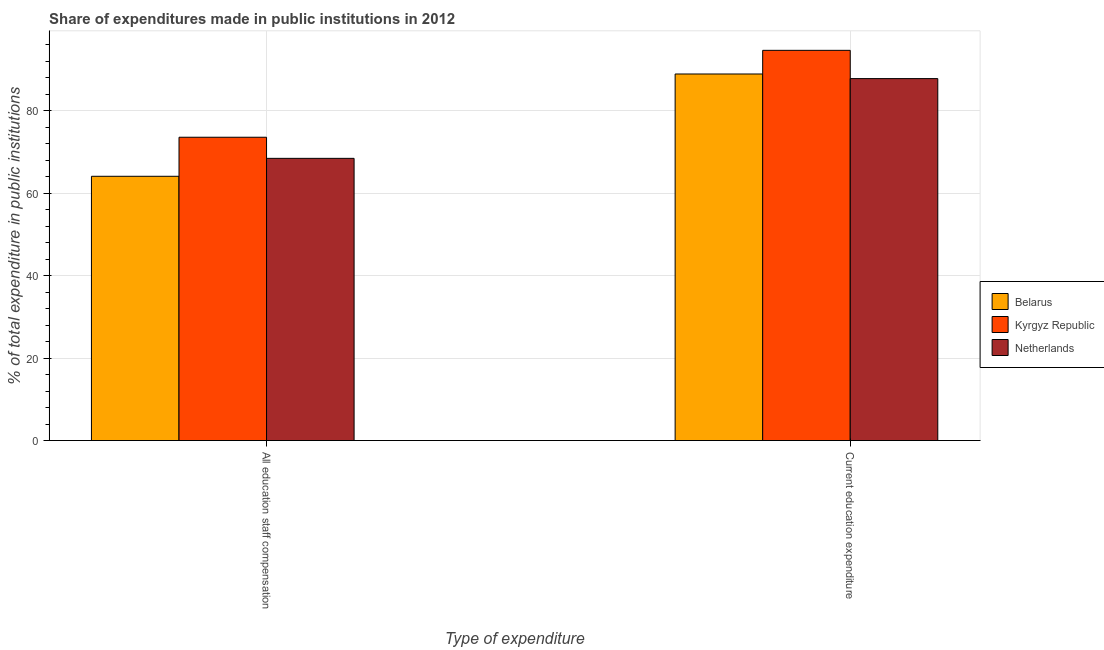How many different coloured bars are there?
Make the answer very short. 3. Are the number of bars per tick equal to the number of legend labels?
Ensure brevity in your answer.  Yes. How many bars are there on the 2nd tick from the right?
Give a very brief answer. 3. What is the label of the 1st group of bars from the left?
Your answer should be compact. All education staff compensation. What is the expenditure in staff compensation in Netherlands?
Make the answer very short. 68.41. Across all countries, what is the maximum expenditure in staff compensation?
Offer a terse response. 73.53. Across all countries, what is the minimum expenditure in staff compensation?
Your answer should be very brief. 64.06. In which country was the expenditure in staff compensation maximum?
Offer a very short reply. Kyrgyz Republic. What is the total expenditure in education in the graph?
Your answer should be compact. 271.19. What is the difference between the expenditure in education in Belarus and that in Netherlands?
Your answer should be very brief. 1.11. What is the difference between the expenditure in staff compensation in Netherlands and the expenditure in education in Kyrgyz Republic?
Provide a short and direct response. -26.18. What is the average expenditure in staff compensation per country?
Your answer should be very brief. 68.66. What is the difference between the expenditure in education and expenditure in staff compensation in Belarus?
Ensure brevity in your answer.  24.79. In how many countries, is the expenditure in staff compensation greater than 12 %?
Keep it short and to the point. 3. What is the ratio of the expenditure in education in Netherlands to that in Kyrgyz Republic?
Provide a short and direct response. 0.93. Is the expenditure in education in Netherlands less than that in Belarus?
Provide a succinct answer. Yes. What does the 1st bar from the left in Current education expenditure represents?
Ensure brevity in your answer.  Belarus. What does the 2nd bar from the right in Current education expenditure represents?
Provide a short and direct response. Kyrgyz Republic. Are all the bars in the graph horizontal?
Your answer should be compact. No. Does the graph contain any zero values?
Provide a succinct answer. No. Where does the legend appear in the graph?
Offer a terse response. Center right. What is the title of the graph?
Your answer should be very brief. Share of expenditures made in public institutions in 2012. What is the label or title of the X-axis?
Provide a succinct answer. Type of expenditure. What is the label or title of the Y-axis?
Provide a succinct answer. % of total expenditure in public institutions. What is the % of total expenditure in public institutions in Belarus in All education staff compensation?
Offer a terse response. 64.06. What is the % of total expenditure in public institutions in Kyrgyz Republic in All education staff compensation?
Give a very brief answer. 73.53. What is the % of total expenditure in public institutions in Netherlands in All education staff compensation?
Your response must be concise. 68.41. What is the % of total expenditure in public institutions of Belarus in Current education expenditure?
Provide a succinct answer. 88.86. What is the % of total expenditure in public institutions in Kyrgyz Republic in Current education expenditure?
Ensure brevity in your answer.  94.59. What is the % of total expenditure in public institutions of Netherlands in Current education expenditure?
Your answer should be compact. 87.74. Across all Type of expenditure, what is the maximum % of total expenditure in public institutions of Belarus?
Your answer should be compact. 88.86. Across all Type of expenditure, what is the maximum % of total expenditure in public institutions in Kyrgyz Republic?
Your answer should be compact. 94.59. Across all Type of expenditure, what is the maximum % of total expenditure in public institutions in Netherlands?
Give a very brief answer. 87.74. Across all Type of expenditure, what is the minimum % of total expenditure in public institutions of Belarus?
Offer a very short reply. 64.06. Across all Type of expenditure, what is the minimum % of total expenditure in public institutions in Kyrgyz Republic?
Provide a short and direct response. 73.53. Across all Type of expenditure, what is the minimum % of total expenditure in public institutions of Netherlands?
Your answer should be very brief. 68.41. What is the total % of total expenditure in public institutions of Belarus in the graph?
Provide a succinct answer. 152.92. What is the total % of total expenditure in public institutions of Kyrgyz Republic in the graph?
Give a very brief answer. 168.12. What is the total % of total expenditure in public institutions of Netherlands in the graph?
Give a very brief answer. 156.15. What is the difference between the % of total expenditure in public institutions of Belarus in All education staff compensation and that in Current education expenditure?
Provide a succinct answer. -24.79. What is the difference between the % of total expenditure in public institutions of Kyrgyz Republic in All education staff compensation and that in Current education expenditure?
Make the answer very short. -21.06. What is the difference between the % of total expenditure in public institutions in Netherlands in All education staff compensation and that in Current education expenditure?
Offer a terse response. -19.33. What is the difference between the % of total expenditure in public institutions in Belarus in All education staff compensation and the % of total expenditure in public institutions in Kyrgyz Republic in Current education expenditure?
Give a very brief answer. -30.53. What is the difference between the % of total expenditure in public institutions in Belarus in All education staff compensation and the % of total expenditure in public institutions in Netherlands in Current education expenditure?
Offer a very short reply. -23.68. What is the difference between the % of total expenditure in public institutions of Kyrgyz Republic in All education staff compensation and the % of total expenditure in public institutions of Netherlands in Current education expenditure?
Ensure brevity in your answer.  -14.21. What is the average % of total expenditure in public institutions of Belarus per Type of expenditure?
Make the answer very short. 76.46. What is the average % of total expenditure in public institutions of Kyrgyz Republic per Type of expenditure?
Provide a succinct answer. 84.06. What is the average % of total expenditure in public institutions in Netherlands per Type of expenditure?
Give a very brief answer. 78.07. What is the difference between the % of total expenditure in public institutions in Belarus and % of total expenditure in public institutions in Kyrgyz Republic in All education staff compensation?
Offer a terse response. -9.47. What is the difference between the % of total expenditure in public institutions of Belarus and % of total expenditure in public institutions of Netherlands in All education staff compensation?
Your answer should be very brief. -4.35. What is the difference between the % of total expenditure in public institutions of Kyrgyz Republic and % of total expenditure in public institutions of Netherlands in All education staff compensation?
Provide a short and direct response. 5.12. What is the difference between the % of total expenditure in public institutions of Belarus and % of total expenditure in public institutions of Kyrgyz Republic in Current education expenditure?
Your response must be concise. -5.74. What is the difference between the % of total expenditure in public institutions of Belarus and % of total expenditure in public institutions of Netherlands in Current education expenditure?
Your answer should be very brief. 1.11. What is the difference between the % of total expenditure in public institutions in Kyrgyz Republic and % of total expenditure in public institutions in Netherlands in Current education expenditure?
Offer a terse response. 6.85. What is the ratio of the % of total expenditure in public institutions of Belarus in All education staff compensation to that in Current education expenditure?
Keep it short and to the point. 0.72. What is the ratio of the % of total expenditure in public institutions in Kyrgyz Republic in All education staff compensation to that in Current education expenditure?
Ensure brevity in your answer.  0.78. What is the ratio of the % of total expenditure in public institutions in Netherlands in All education staff compensation to that in Current education expenditure?
Provide a short and direct response. 0.78. What is the difference between the highest and the second highest % of total expenditure in public institutions in Belarus?
Your answer should be compact. 24.79. What is the difference between the highest and the second highest % of total expenditure in public institutions in Kyrgyz Republic?
Make the answer very short. 21.06. What is the difference between the highest and the second highest % of total expenditure in public institutions of Netherlands?
Keep it short and to the point. 19.33. What is the difference between the highest and the lowest % of total expenditure in public institutions in Belarus?
Provide a succinct answer. 24.79. What is the difference between the highest and the lowest % of total expenditure in public institutions in Kyrgyz Republic?
Provide a short and direct response. 21.06. What is the difference between the highest and the lowest % of total expenditure in public institutions in Netherlands?
Your answer should be compact. 19.33. 